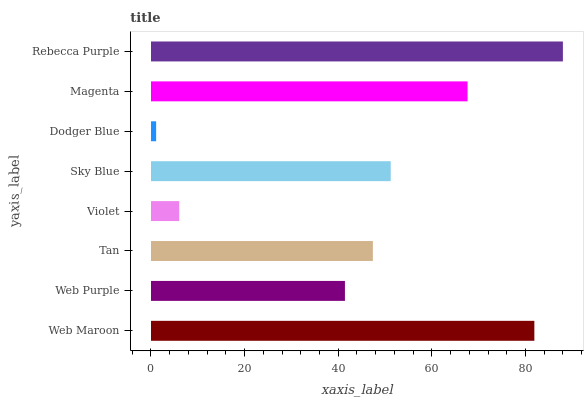Is Dodger Blue the minimum?
Answer yes or no. Yes. Is Rebecca Purple the maximum?
Answer yes or no. Yes. Is Web Purple the minimum?
Answer yes or no. No. Is Web Purple the maximum?
Answer yes or no. No. Is Web Maroon greater than Web Purple?
Answer yes or no. Yes. Is Web Purple less than Web Maroon?
Answer yes or no. Yes. Is Web Purple greater than Web Maroon?
Answer yes or no. No. Is Web Maroon less than Web Purple?
Answer yes or no. No. Is Sky Blue the high median?
Answer yes or no. Yes. Is Tan the low median?
Answer yes or no. Yes. Is Rebecca Purple the high median?
Answer yes or no. No. Is Web Purple the low median?
Answer yes or no. No. 